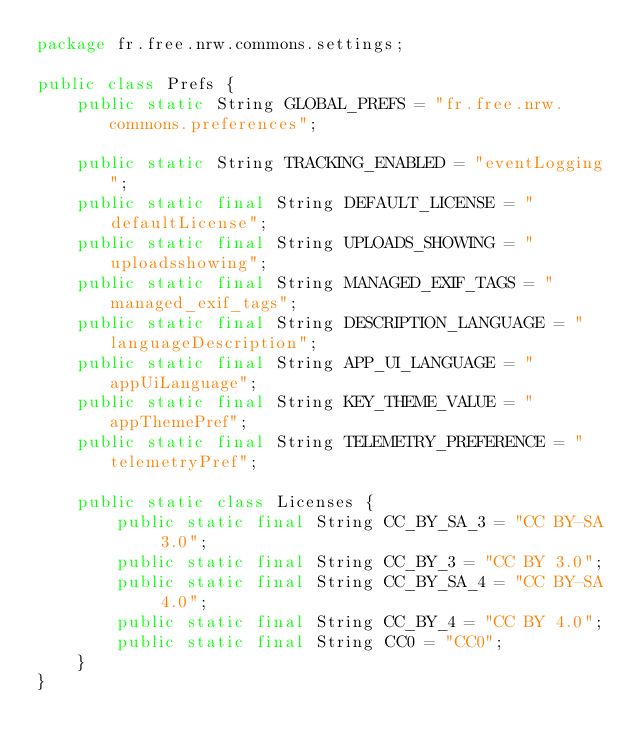Convert code to text. <code><loc_0><loc_0><loc_500><loc_500><_Java_>package fr.free.nrw.commons.settings;

public class Prefs {
    public static String GLOBAL_PREFS = "fr.free.nrw.commons.preferences";

    public static String TRACKING_ENABLED = "eventLogging";
    public static final String DEFAULT_LICENSE = "defaultLicense";
    public static final String UPLOADS_SHOWING = "uploadsshowing";
    public static final String MANAGED_EXIF_TAGS = "managed_exif_tags";
    public static final String DESCRIPTION_LANGUAGE = "languageDescription";
    public static final String APP_UI_LANGUAGE = "appUiLanguage";
    public static final String KEY_THEME_VALUE = "appThemePref";
    public static final String TELEMETRY_PREFERENCE = "telemetryPref";

    public static class Licenses {
        public static final String CC_BY_SA_3 = "CC BY-SA 3.0";
        public static final String CC_BY_3 = "CC BY 3.0";
        public static final String CC_BY_SA_4 = "CC BY-SA 4.0";
        public static final String CC_BY_4 = "CC BY 4.0";
        public static final String CC0 = "CC0";
    }
}
</code> 